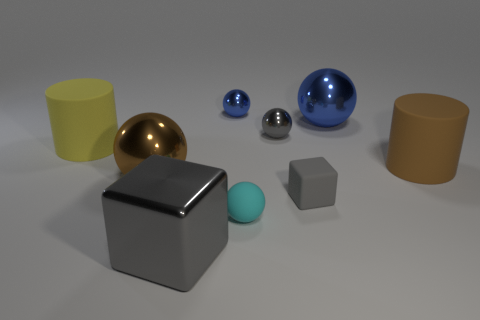Subtract all brown balls. How many balls are left? 4 Subtract all matte spheres. How many spheres are left? 4 Subtract all green spheres. Subtract all gray blocks. How many spheres are left? 5 Subtract all cylinders. How many objects are left? 7 Subtract all tiny shiny spheres. Subtract all large rubber objects. How many objects are left? 5 Add 4 small shiny balls. How many small shiny balls are left? 6 Add 7 gray blocks. How many gray blocks exist? 9 Subtract 0 red blocks. How many objects are left? 9 